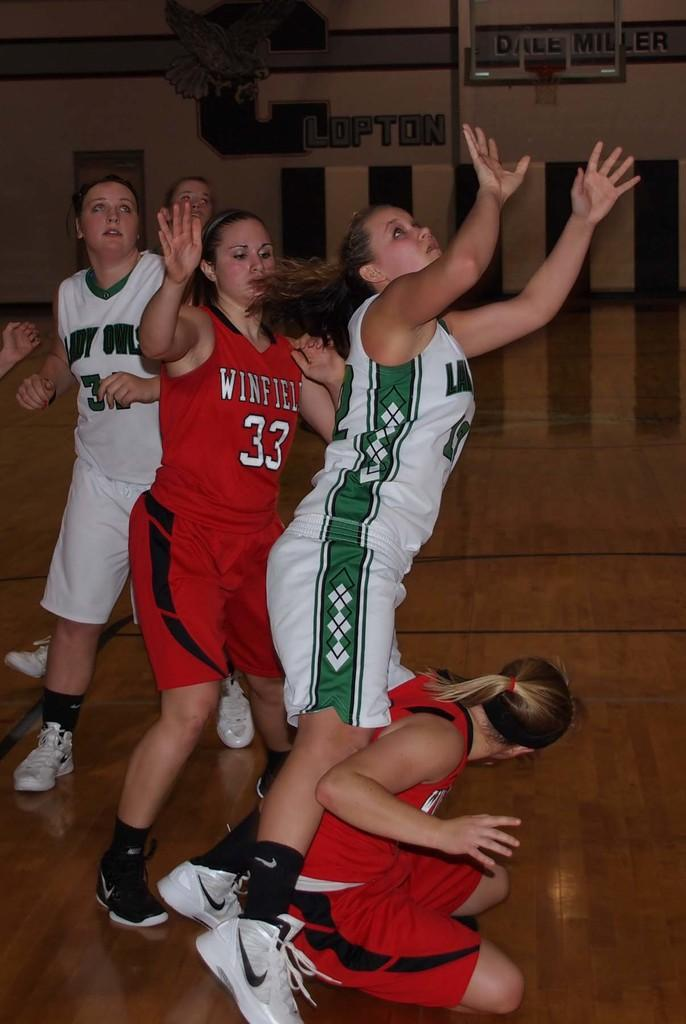<image>
Summarize the visual content of the image. Winfield are playing volley ball against the owls 